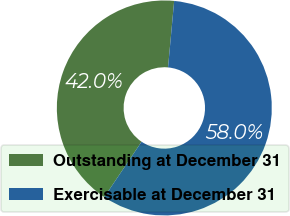<chart> <loc_0><loc_0><loc_500><loc_500><pie_chart><fcel>Outstanding at December 31<fcel>Exercisable at December 31<nl><fcel>42.03%<fcel>57.97%<nl></chart> 